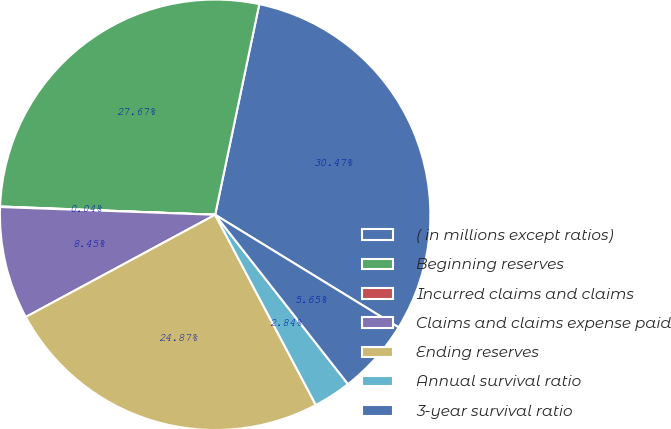<chart> <loc_0><loc_0><loc_500><loc_500><pie_chart><fcel>( in millions except ratios)<fcel>Beginning reserves<fcel>Incurred claims and claims<fcel>Claims and claims expense paid<fcel>Ending reserves<fcel>Annual survival ratio<fcel>3-year survival ratio<nl><fcel>30.47%<fcel>27.67%<fcel>0.04%<fcel>8.45%<fcel>24.87%<fcel>2.84%<fcel>5.65%<nl></chart> 